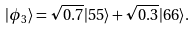Convert formula to latex. <formula><loc_0><loc_0><loc_500><loc_500>| \phi _ { 3 } \rangle = \sqrt { 0 . 7 } | 5 5 \rangle + \sqrt { 0 . 3 } | 6 6 \rangle .</formula> 